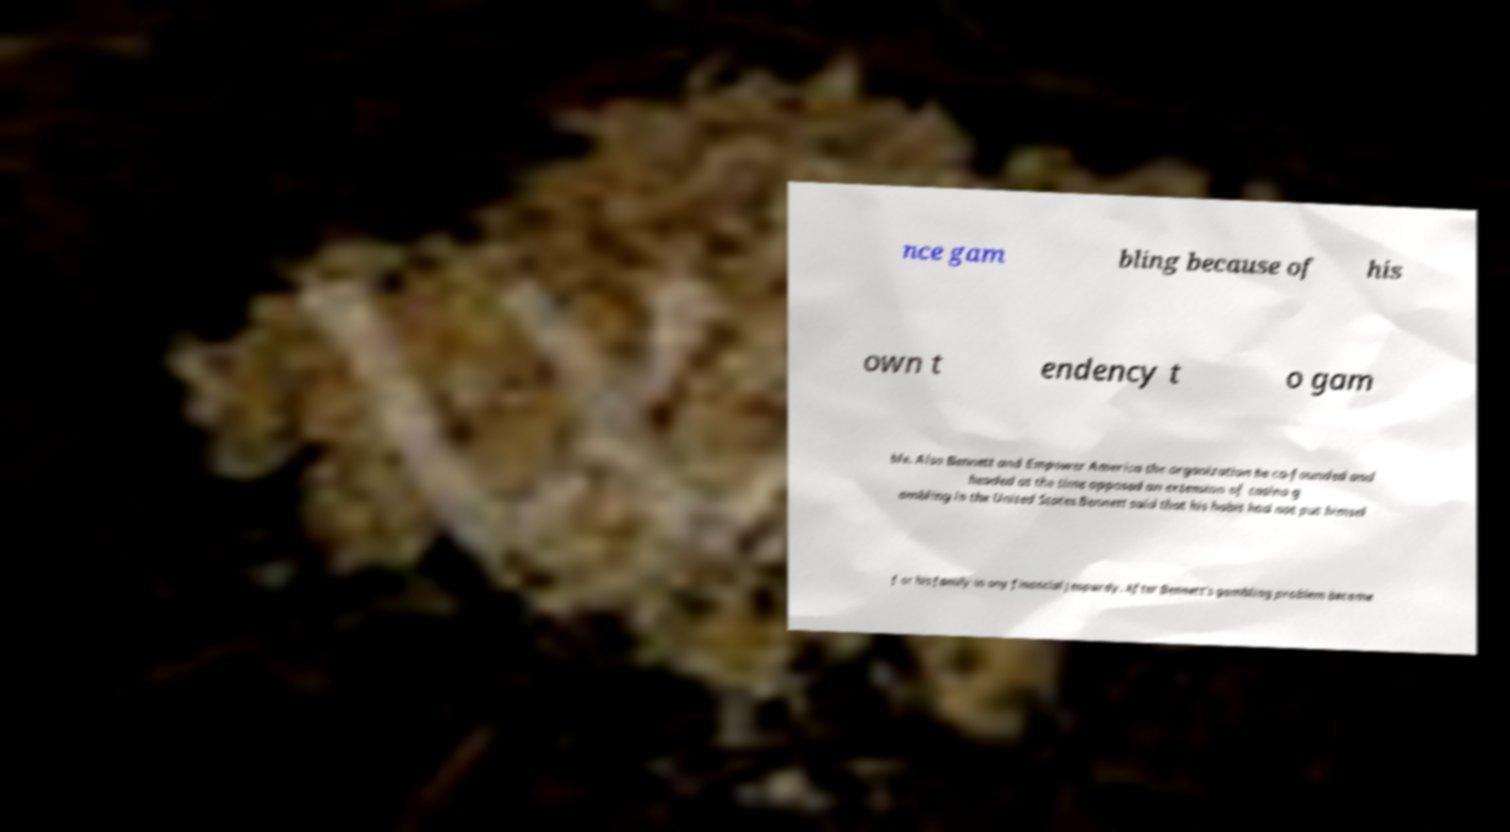There's text embedded in this image that I need extracted. Can you transcribe it verbatim? nce gam bling because of his own t endency t o gam ble. Also Bennett and Empower America the organization he co-founded and headed at the time opposed an extension of casino g ambling in the United States.Bennett said that his habit had not put himsel f or his family in any financial jeopardy. After Bennett's gambling problem became 